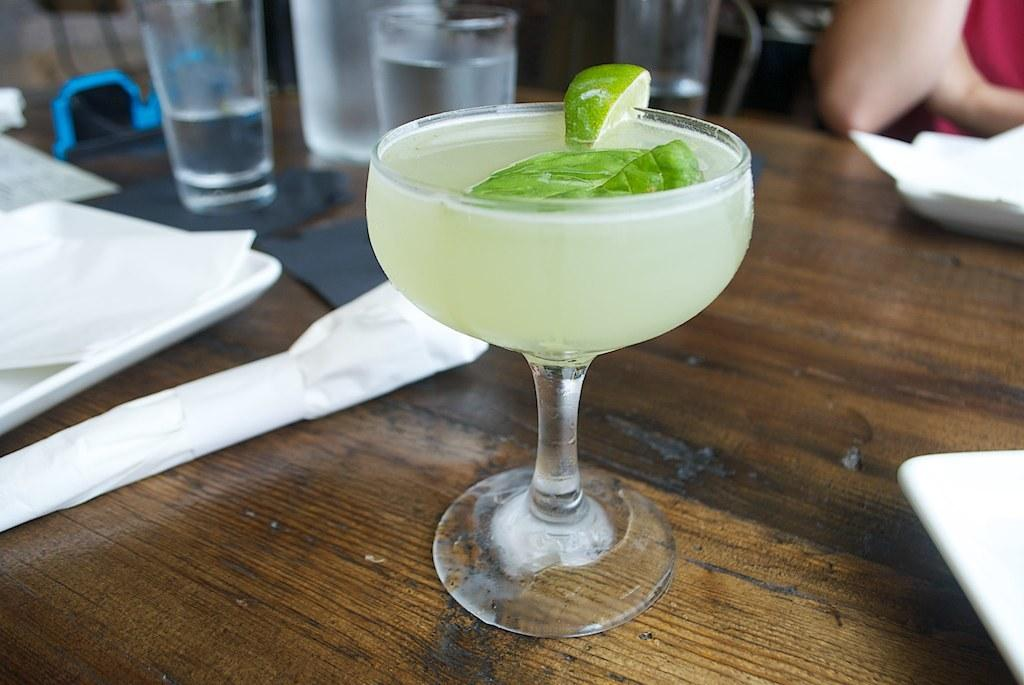What type of glass is in the image? There is a lemon cocktail glass in the image. Where is the lemon cocktail glass placed? The lemon cocktail glass is placed on a wooden table top. What other type of glass can be seen in the image? There are water glasses in the image. How are the water glasses arranged in the image? The water glasses are placed on a white tray. Is there a snake fighting with someone in the image? No, there is no snake or fight depicted in the image. 